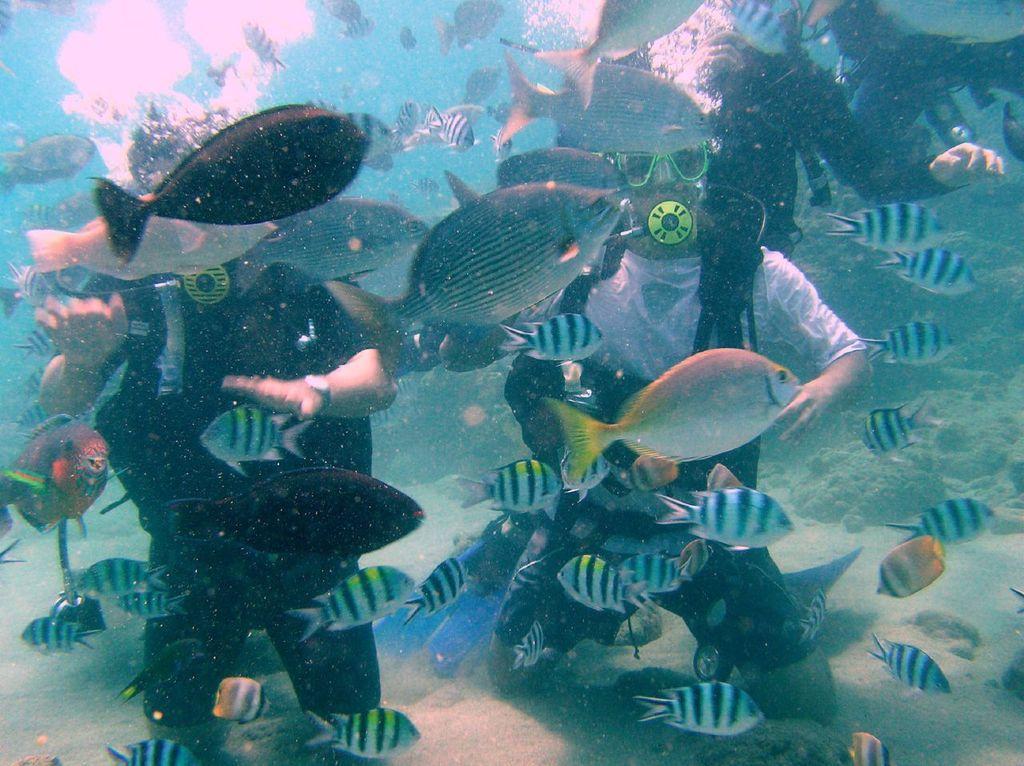Can you describe this image briefly? In this there are two people visible under water, wearing regulators, there are few fishes visible and there is another person visible at the top, underwater. 